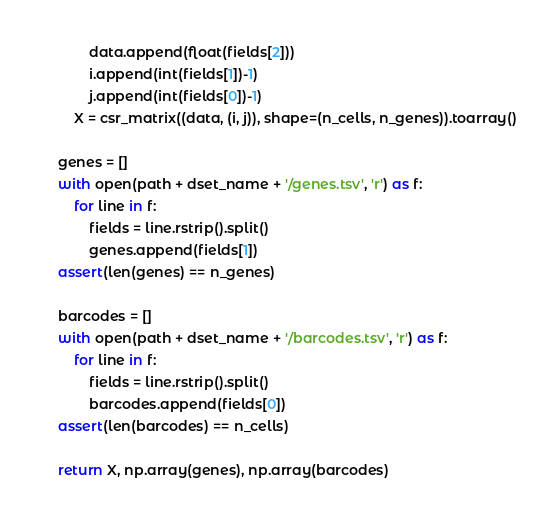Convert code to text. <code><loc_0><loc_0><loc_500><loc_500><_Python_>            data.append(float(fields[2]))
            i.append(int(fields[1])-1)
            j.append(int(fields[0])-1)
        X = csr_matrix((data, (i, j)), shape=(n_cells, n_genes)).toarray()

    genes = []
    with open(path + dset_name + '/genes.tsv', 'r') as f:
        for line in f:
            fields = line.rstrip().split()
            genes.append(fields[1])
    assert(len(genes) == n_genes)

    barcodes = []
    with open(path + dset_name + '/barcodes.tsv', 'r') as f:
        for line in f:
            fields = line.rstrip().split()
            barcodes.append(fields[0])
    assert(len(barcodes) == n_cells)

    return X, np.array(genes), np.array(barcodes)</code> 